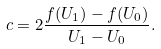Convert formula to latex. <formula><loc_0><loc_0><loc_500><loc_500>c = 2 \frac { f ( U _ { 1 } ) - f ( U _ { 0 } ) } { U _ { 1 } - U _ { 0 } } .</formula> 